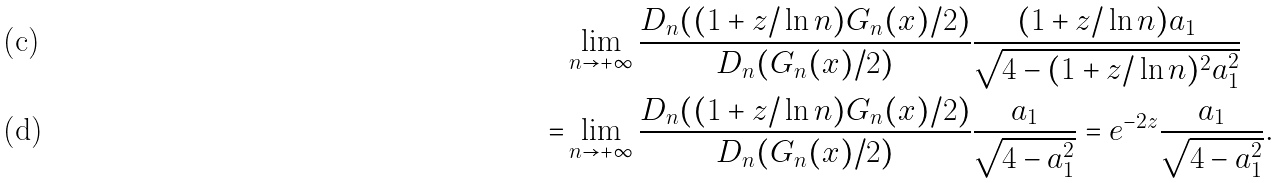<formula> <loc_0><loc_0><loc_500><loc_500>& \lim _ { n \to + \infty } \frac { D _ { n } ( ( 1 + z / \ln n ) G _ { n } ( x ) / 2 ) } { D _ { n } ( G _ { n } ( x ) / 2 ) } \frac { ( 1 + z / \ln n ) a _ { 1 } } { \sqrt { 4 - ( 1 + z / \ln n ) ^ { 2 } a _ { 1 } ^ { 2 } } } \\ = & \lim _ { n \to + \infty } \frac { D _ { n } ( ( 1 + z / \ln n ) G _ { n } ( x ) / 2 ) } { D _ { n } ( G _ { n } ( x ) / 2 ) } \frac { a _ { 1 } } { \sqrt { 4 - a _ { 1 } ^ { 2 } } } = e ^ { - 2 z } \frac { a _ { 1 } } { \sqrt { 4 - a _ { 1 } ^ { 2 } } } .</formula> 